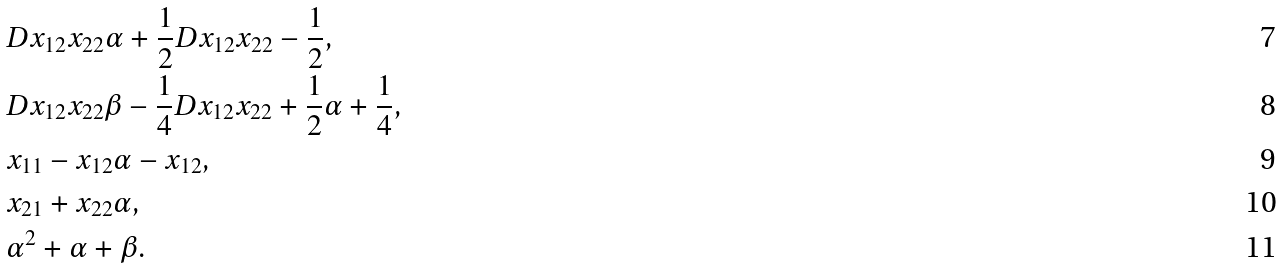Convert formula to latex. <formula><loc_0><loc_0><loc_500><loc_500>& D x _ { 1 2 } x _ { 2 2 } \alpha + \frac { 1 } { 2 } D x _ { 1 2 } x _ { 2 2 } - \frac { 1 } { 2 } , \\ & D x _ { 1 2 } x _ { 2 2 } \beta - \frac { 1 } { 4 } D x _ { 1 2 } x _ { 2 2 } + \frac { 1 } { 2 } \alpha + \frac { 1 } { 4 } , \\ & x _ { 1 1 } - x _ { 1 2 } \alpha - x _ { 1 2 } , \\ & x _ { 2 1 } + x _ { 2 2 } \alpha , \\ & \alpha ^ { 2 } + \alpha + \beta .</formula> 